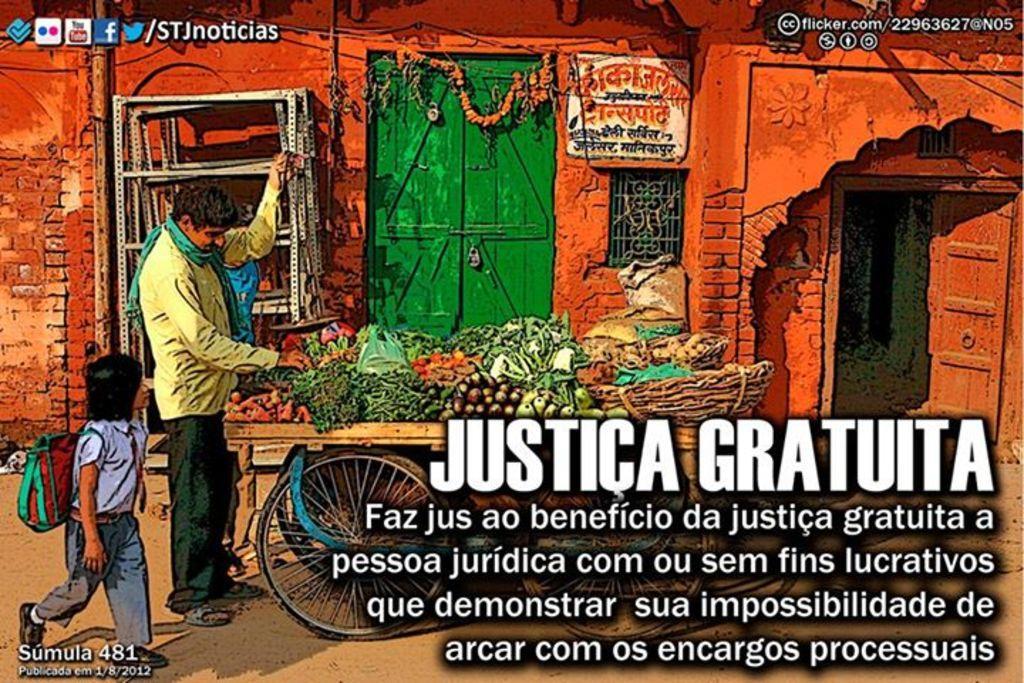Could you give a brief overview of what you see in this image? This image is a poster. On the right side of the image there is a text. At the bottom of the image there is a ground. In the middle of the image there is a cart with many vegetables and baskets on it. On the left side of the image a man is standing on the ground and a kid is walking. In the background there is a house with a wall, a window, door and a board with text on it. 